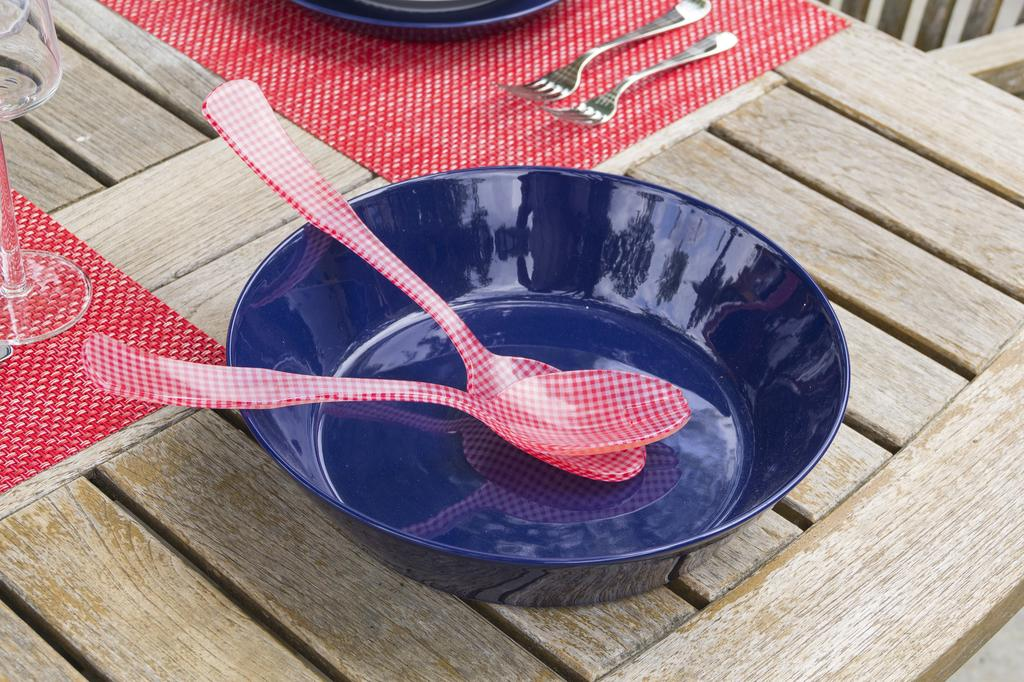What is in the bowl that is visible in the image? There is no information about the contents of the bowl in the provided facts. Besides the bowl, what other items can be seen in the image? There are spoons and forks visible in the image. Where are these utensils located in the image? The spoons and forks are likely on the table in the image. What might be used to protect the table from spills or heat in the image? Mats are present in the image for this purpose. Can you tell me how many robins are involved in the plot of the image? There is no mention of robins or any plot in the provided facts, so this question cannot be answered. 